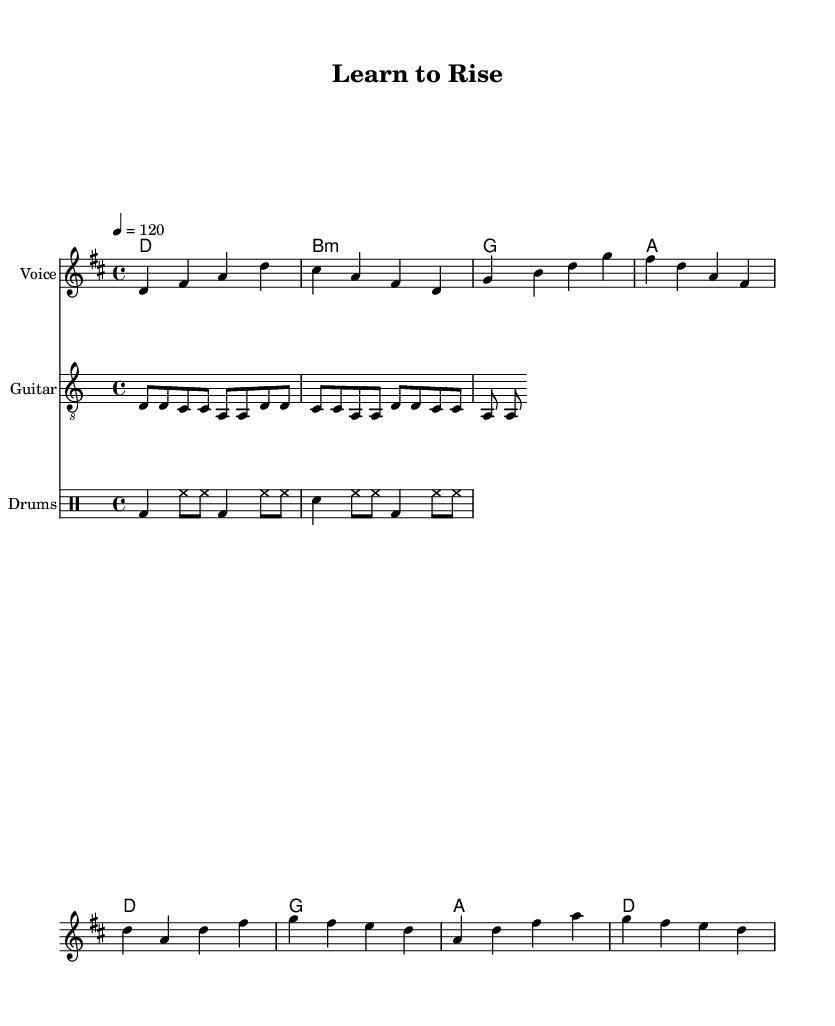What is the key signature of this music? The key signature indicated at the beginning of the score shows two sharps, which corresponds to the key of D major.
Answer: D major What is the time signature of this music? The time signature shown at the beginning of the score is 4/4, meaning there are four beats in each measure and a quarter note receives one beat.
Answer: 4/4 What is the tempo marking? The tempo marking given in the score states that the piece should be played at a speed of 120 beats per minute, indicating the desired pace of performance.
Answer: 120 How many measures are in the verse section? By counting the measures in the melody section labeled as "Verse," there are four measures total, which indicates the structure for this part of the song.
Answer: 4 What is the main theme of the song as suggested by the lyrics? The lyrics in the verse express themes of educational access and enlightenment, indicating a focus on social issues related to education and reform.
Answer: Education Which instrument is featured for the guitar part? The score specifies a staff labeled “Guitar,” indicating that this instrument plays the accompanying part with riffs, typical in rock music.
Answer: Guitar What type of chord is used in the second measure of the verse? The second measure of the verse shows the chord labeled as "B minor," indicated by the use of "b" and the minor chord symbol in the chord progression.
Answer: B minor 